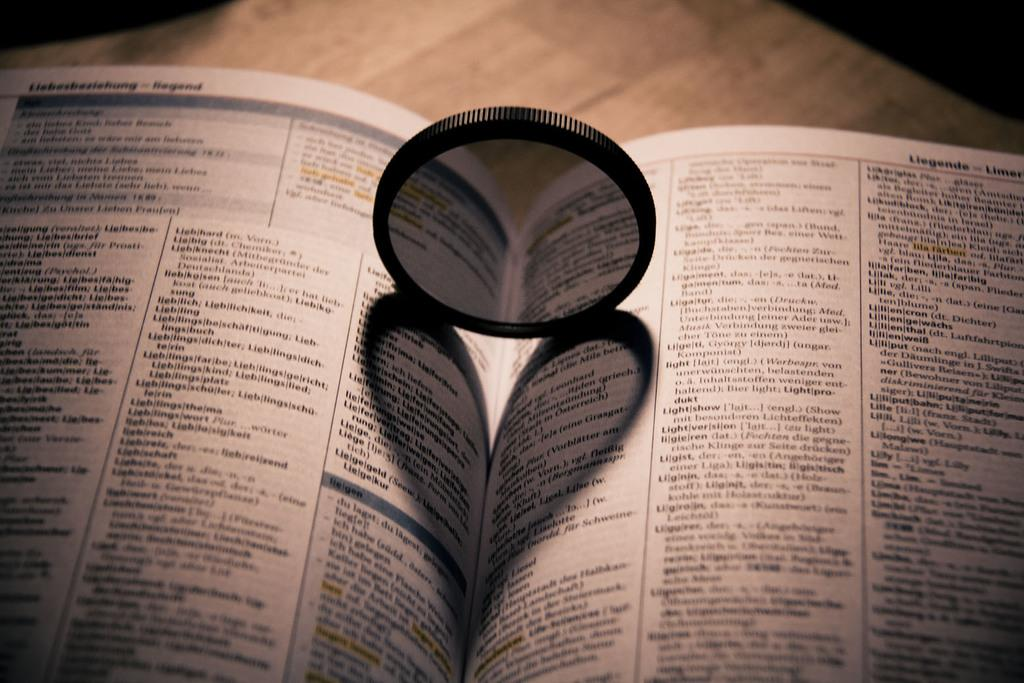<image>
Render a clear and concise summary of the photo. A camera lens is on an open book that says Liegende. 